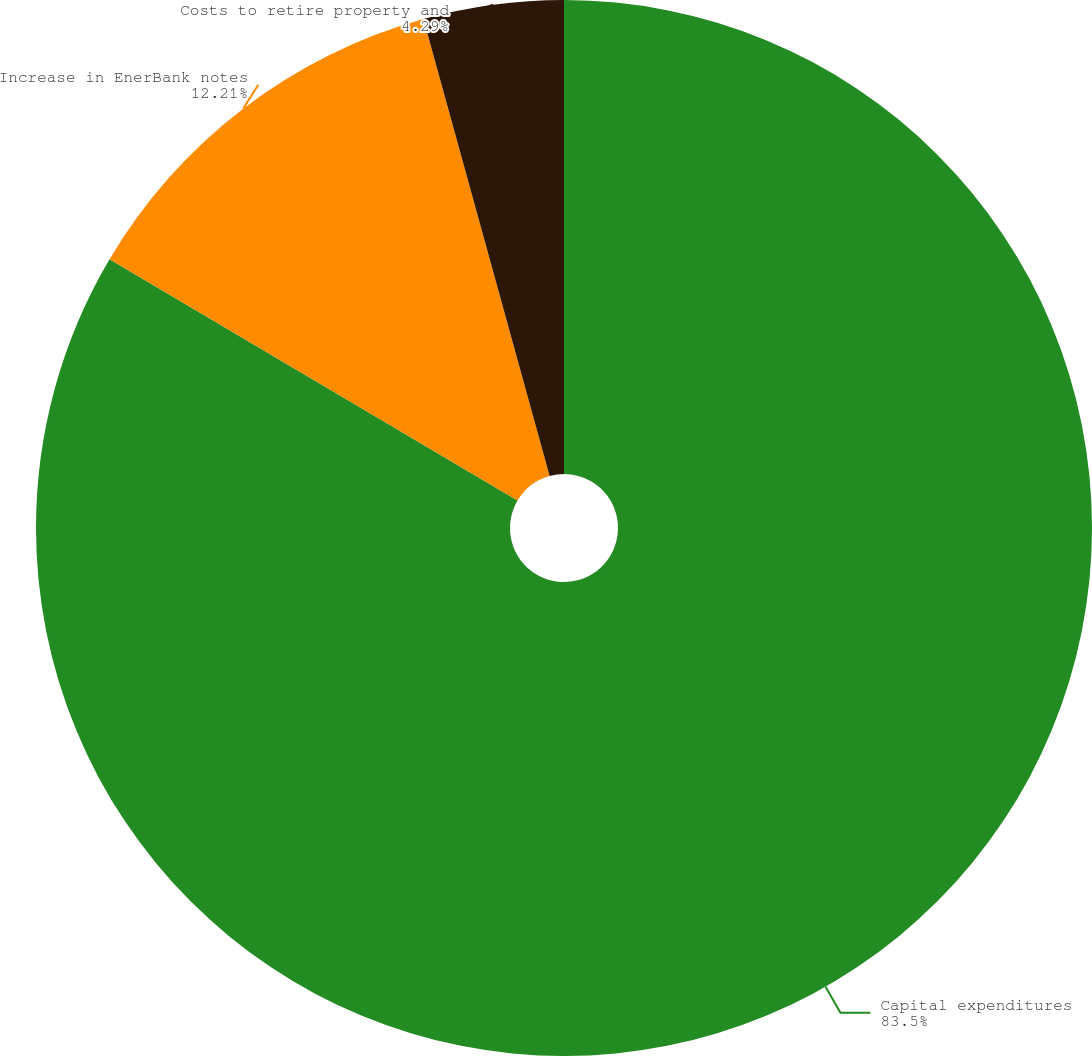<chart> <loc_0><loc_0><loc_500><loc_500><pie_chart><fcel>Capital expenditures<fcel>Increase in EnerBank notes<fcel>Costs to retire property and<nl><fcel>83.51%<fcel>12.21%<fcel>4.29%<nl></chart> 